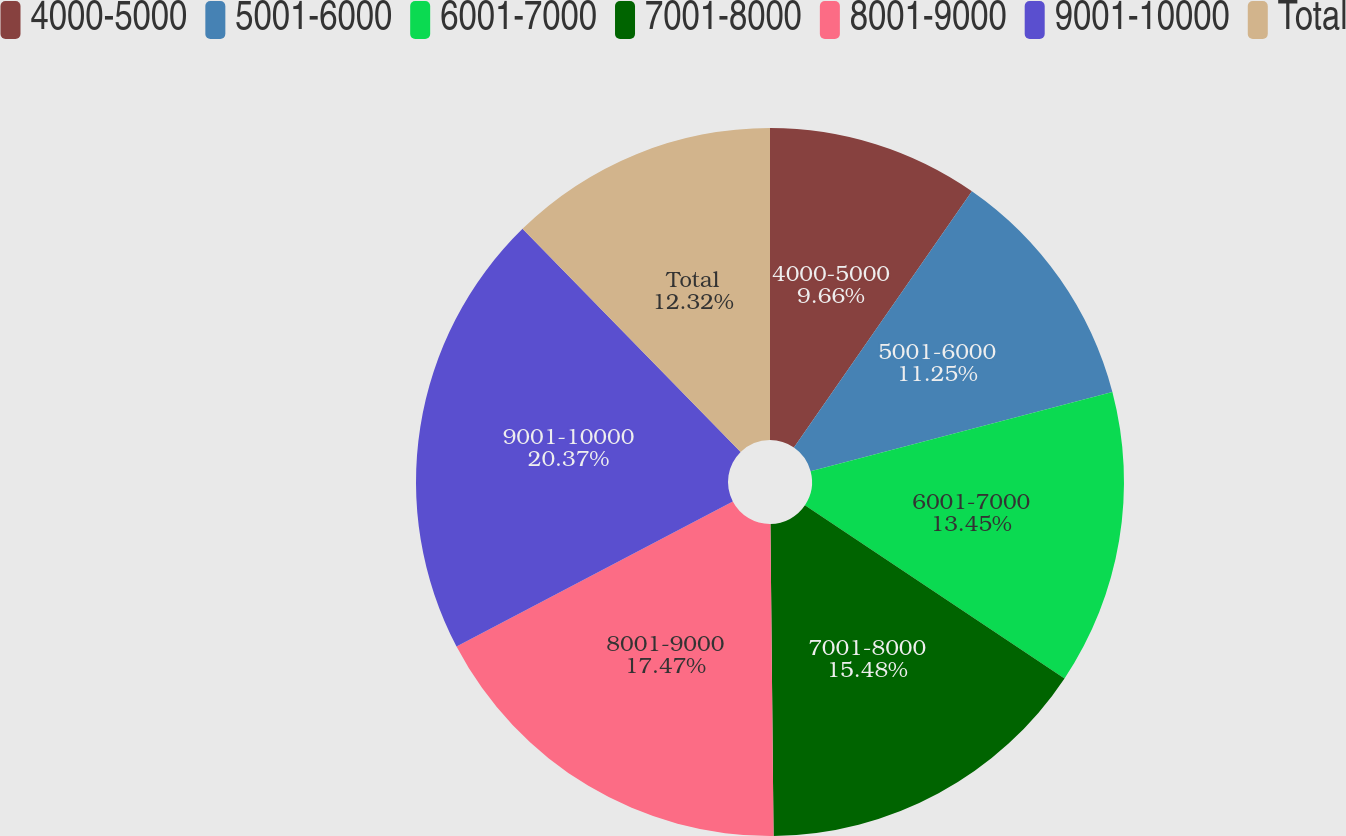<chart> <loc_0><loc_0><loc_500><loc_500><pie_chart><fcel>4000-5000<fcel>5001-6000<fcel>6001-7000<fcel>7001-8000<fcel>8001-9000<fcel>9001-10000<fcel>Total<nl><fcel>9.66%<fcel>11.25%<fcel>13.45%<fcel>15.48%<fcel>17.47%<fcel>20.37%<fcel>12.32%<nl></chart> 